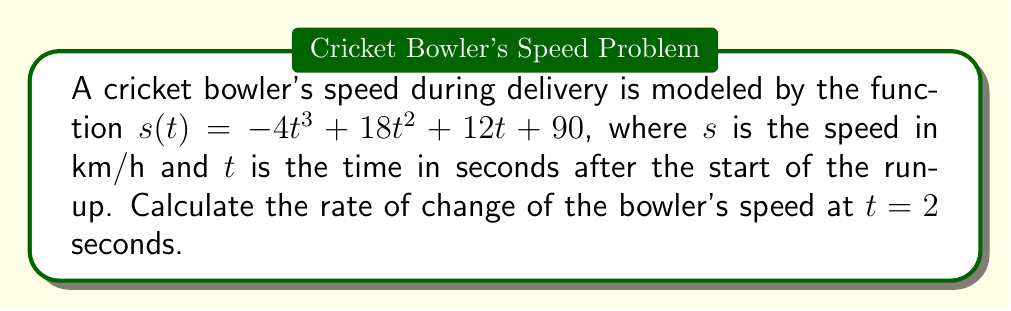Can you solve this math problem? To find the rate of change of the bowler's speed at $t = 2$ seconds, we need to calculate the derivative of the speed function $s(t)$ and evaluate it at $t = 2$.

Step 1: Find the derivative of $s(t)$
$$\frac{d}{dt}s(t) = \frac{d}{dt}(-4t^3 + 18t^2 + 12t + 90)$$
$$s'(t) = -12t^2 + 36t + 12$$

Step 2: Evaluate $s'(t)$ at $t = 2$
$$s'(2) = -12(2)^2 + 36(2) + 12$$
$$s'(2) = -12(4) + 72 + 12$$
$$s'(2) = -48 + 72 + 12$$
$$s'(2) = 36$$

Therefore, the rate of change of the bowler's speed at $t = 2$ seconds is 36 km/h/s.
Answer: 36 km/h/s 